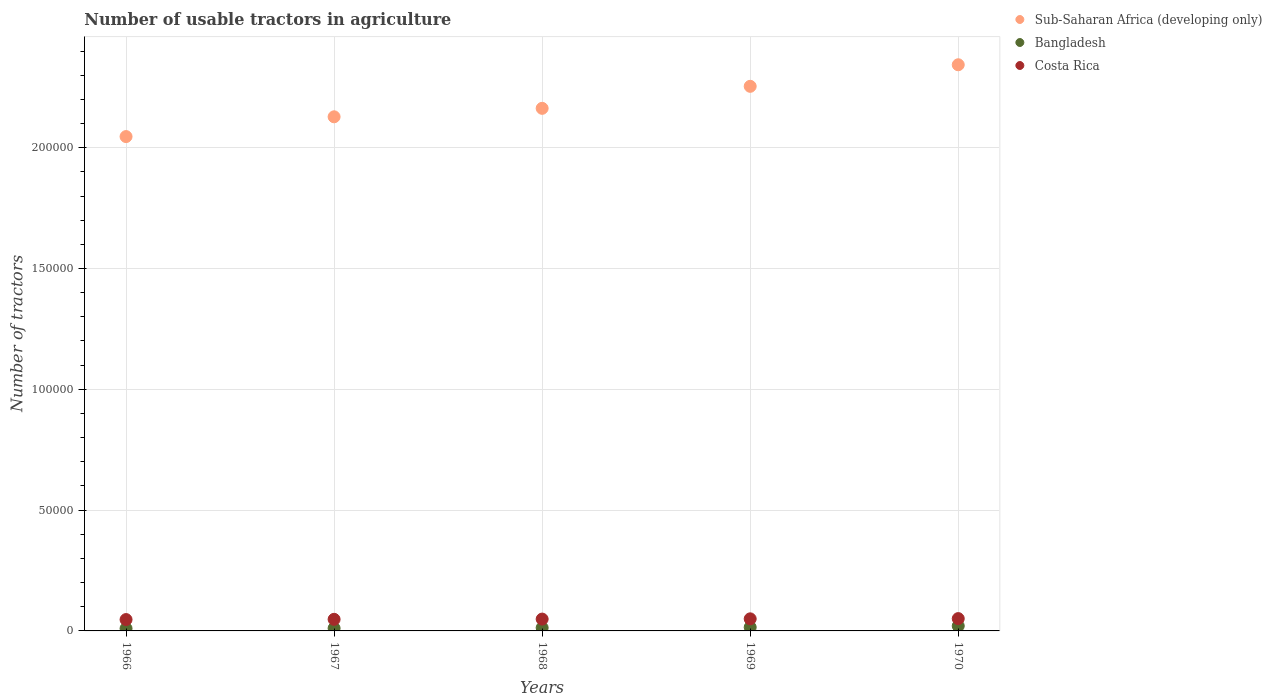Is the number of dotlines equal to the number of legend labels?
Offer a terse response. Yes. What is the number of usable tractors in agriculture in Costa Rica in 1966?
Your answer should be compact. 4700. Across all years, what is the maximum number of usable tractors in agriculture in Bangladesh?
Offer a terse response. 2072. Across all years, what is the minimum number of usable tractors in agriculture in Sub-Saharan Africa (developing only)?
Provide a short and direct response. 2.05e+05. In which year was the number of usable tractors in agriculture in Sub-Saharan Africa (developing only) maximum?
Offer a terse response. 1970. In which year was the number of usable tractors in agriculture in Bangladesh minimum?
Your response must be concise. 1966. What is the total number of usable tractors in agriculture in Bangladesh in the graph?
Provide a short and direct response. 6972. What is the difference between the number of usable tractors in agriculture in Bangladesh in 1968 and that in 1969?
Provide a short and direct response. -200. What is the difference between the number of usable tractors in agriculture in Sub-Saharan Africa (developing only) in 1966 and the number of usable tractors in agriculture in Costa Rica in 1968?
Provide a short and direct response. 2.00e+05. What is the average number of usable tractors in agriculture in Sub-Saharan Africa (developing only) per year?
Keep it short and to the point. 2.19e+05. In the year 1967, what is the difference between the number of usable tractors in agriculture in Bangladesh and number of usable tractors in agriculture in Costa Rica?
Make the answer very short. -3700. What is the ratio of the number of usable tractors in agriculture in Sub-Saharan Africa (developing only) in 1966 to that in 1968?
Provide a short and direct response. 0.95. Is the difference between the number of usable tractors in agriculture in Bangladesh in 1966 and 1969 greater than the difference between the number of usable tractors in agriculture in Costa Rica in 1966 and 1969?
Provide a short and direct response. No. What is the difference between the highest and the lowest number of usable tractors in agriculture in Sub-Saharan Africa (developing only)?
Give a very brief answer. 2.97e+04. In how many years, is the number of usable tractors in agriculture in Sub-Saharan Africa (developing only) greater than the average number of usable tractors in agriculture in Sub-Saharan Africa (developing only) taken over all years?
Make the answer very short. 2. Is the number of usable tractors in agriculture in Bangladesh strictly less than the number of usable tractors in agriculture in Sub-Saharan Africa (developing only) over the years?
Keep it short and to the point. Yes. How many years are there in the graph?
Ensure brevity in your answer.  5. What is the difference between two consecutive major ticks on the Y-axis?
Provide a short and direct response. 5.00e+04. Does the graph contain any zero values?
Your response must be concise. No. How many legend labels are there?
Your answer should be compact. 3. What is the title of the graph?
Ensure brevity in your answer.  Number of usable tractors in agriculture. What is the label or title of the X-axis?
Your answer should be very brief. Years. What is the label or title of the Y-axis?
Keep it short and to the point. Number of tractors. What is the Number of tractors of Sub-Saharan Africa (developing only) in 1966?
Provide a short and direct response. 2.05e+05. What is the Number of tractors in Costa Rica in 1966?
Ensure brevity in your answer.  4700. What is the Number of tractors of Sub-Saharan Africa (developing only) in 1967?
Your answer should be very brief. 2.13e+05. What is the Number of tractors in Bangladesh in 1967?
Your answer should be very brief. 1100. What is the Number of tractors in Costa Rica in 1967?
Your response must be concise. 4800. What is the Number of tractors of Sub-Saharan Africa (developing only) in 1968?
Offer a very short reply. 2.16e+05. What is the Number of tractors in Bangladesh in 1968?
Give a very brief answer. 1300. What is the Number of tractors of Costa Rica in 1968?
Keep it short and to the point. 4900. What is the Number of tractors in Sub-Saharan Africa (developing only) in 1969?
Your answer should be compact. 2.25e+05. What is the Number of tractors in Bangladesh in 1969?
Offer a very short reply. 1500. What is the Number of tractors of Sub-Saharan Africa (developing only) in 1970?
Make the answer very short. 2.34e+05. What is the Number of tractors of Bangladesh in 1970?
Offer a very short reply. 2072. What is the Number of tractors of Costa Rica in 1970?
Provide a succinct answer. 5100. Across all years, what is the maximum Number of tractors in Sub-Saharan Africa (developing only)?
Provide a short and direct response. 2.34e+05. Across all years, what is the maximum Number of tractors in Bangladesh?
Provide a short and direct response. 2072. Across all years, what is the maximum Number of tractors of Costa Rica?
Your response must be concise. 5100. Across all years, what is the minimum Number of tractors in Sub-Saharan Africa (developing only)?
Provide a short and direct response. 2.05e+05. Across all years, what is the minimum Number of tractors of Costa Rica?
Your answer should be compact. 4700. What is the total Number of tractors of Sub-Saharan Africa (developing only) in the graph?
Give a very brief answer. 1.09e+06. What is the total Number of tractors in Bangladesh in the graph?
Make the answer very short. 6972. What is the total Number of tractors in Costa Rica in the graph?
Your answer should be very brief. 2.45e+04. What is the difference between the Number of tractors of Sub-Saharan Africa (developing only) in 1966 and that in 1967?
Make the answer very short. -8186. What is the difference between the Number of tractors in Bangladesh in 1966 and that in 1967?
Offer a very short reply. -100. What is the difference between the Number of tractors of Costa Rica in 1966 and that in 1967?
Your answer should be compact. -100. What is the difference between the Number of tractors of Sub-Saharan Africa (developing only) in 1966 and that in 1968?
Keep it short and to the point. -1.17e+04. What is the difference between the Number of tractors of Bangladesh in 1966 and that in 1968?
Ensure brevity in your answer.  -300. What is the difference between the Number of tractors in Costa Rica in 1966 and that in 1968?
Your answer should be very brief. -200. What is the difference between the Number of tractors in Sub-Saharan Africa (developing only) in 1966 and that in 1969?
Keep it short and to the point. -2.08e+04. What is the difference between the Number of tractors in Bangladesh in 1966 and that in 1969?
Your answer should be compact. -500. What is the difference between the Number of tractors in Costa Rica in 1966 and that in 1969?
Your answer should be very brief. -300. What is the difference between the Number of tractors in Sub-Saharan Africa (developing only) in 1966 and that in 1970?
Offer a terse response. -2.97e+04. What is the difference between the Number of tractors in Bangladesh in 1966 and that in 1970?
Your answer should be compact. -1072. What is the difference between the Number of tractors in Costa Rica in 1966 and that in 1970?
Provide a short and direct response. -400. What is the difference between the Number of tractors in Sub-Saharan Africa (developing only) in 1967 and that in 1968?
Ensure brevity in your answer.  -3501. What is the difference between the Number of tractors of Bangladesh in 1967 and that in 1968?
Your response must be concise. -200. What is the difference between the Number of tractors of Costa Rica in 1967 and that in 1968?
Make the answer very short. -100. What is the difference between the Number of tractors of Sub-Saharan Africa (developing only) in 1967 and that in 1969?
Ensure brevity in your answer.  -1.26e+04. What is the difference between the Number of tractors of Bangladesh in 1967 and that in 1969?
Ensure brevity in your answer.  -400. What is the difference between the Number of tractors of Costa Rica in 1967 and that in 1969?
Provide a short and direct response. -200. What is the difference between the Number of tractors in Sub-Saharan Africa (developing only) in 1967 and that in 1970?
Your answer should be very brief. -2.15e+04. What is the difference between the Number of tractors of Bangladesh in 1967 and that in 1970?
Offer a terse response. -972. What is the difference between the Number of tractors in Costa Rica in 1967 and that in 1970?
Offer a terse response. -300. What is the difference between the Number of tractors in Sub-Saharan Africa (developing only) in 1968 and that in 1969?
Provide a succinct answer. -9111. What is the difference between the Number of tractors of Bangladesh in 1968 and that in 1969?
Ensure brevity in your answer.  -200. What is the difference between the Number of tractors of Costa Rica in 1968 and that in 1969?
Make the answer very short. -100. What is the difference between the Number of tractors in Sub-Saharan Africa (developing only) in 1968 and that in 1970?
Your answer should be very brief. -1.80e+04. What is the difference between the Number of tractors in Bangladesh in 1968 and that in 1970?
Make the answer very short. -772. What is the difference between the Number of tractors in Costa Rica in 1968 and that in 1970?
Your answer should be compact. -200. What is the difference between the Number of tractors in Sub-Saharan Africa (developing only) in 1969 and that in 1970?
Your answer should be very brief. -8924. What is the difference between the Number of tractors of Bangladesh in 1969 and that in 1970?
Offer a very short reply. -572. What is the difference between the Number of tractors in Costa Rica in 1969 and that in 1970?
Give a very brief answer. -100. What is the difference between the Number of tractors in Sub-Saharan Africa (developing only) in 1966 and the Number of tractors in Bangladesh in 1967?
Your answer should be very brief. 2.03e+05. What is the difference between the Number of tractors in Sub-Saharan Africa (developing only) in 1966 and the Number of tractors in Costa Rica in 1967?
Provide a succinct answer. 2.00e+05. What is the difference between the Number of tractors in Bangladesh in 1966 and the Number of tractors in Costa Rica in 1967?
Give a very brief answer. -3800. What is the difference between the Number of tractors of Sub-Saharan Africa (developing only) in 1966 and the Number of tractors of Bangladesh in 1968?
Your answer should be very brief. 2.03e+05. What is the difference between the Number of tractors of Sub-Saharan Africa (developing only) in 1966 and the Number of tractors of Costa Rica in 1968?
Your answer should be very brief. 2.00e+05. What is the difference between the Number of tractors of Bangladesh in 1966 and the Number of tractors of Costa Rica in 1968?
Keep it short and to the point. -3900. What is the difference between the Number of tractors in Sub-Saharan Africa (developing only) in 1966 and the Number of tractors in Bangladesh in 1969?
Your answer should be compact. 2.03e+05. What is the difference between the Number of tractors of Sub-Saharan Africa (developing only) in 1966 and the Number of tractors of Costa Rica in 1969?
Your answer should be compact. 2.00e+05. What is the difference between the Number of tractors of Bangladesh in 1966 and the Number of tractors of Costa Rica in 1969?
Ensure brevity in your answer.  -4000. What is the difference between the Number of tractors in Sub-Saharan Africa (developing only) in 1966 and the Number of tractors in Bangladesh in 1970?
Offer a terse response. 2.03e+05. What is the difference between the Number of tractors in Sub-Saharan Africa (developing only) in 1966 and the Number of tractors in Costa Rica in 1970?
Offer a very short reply. 1.99e+05. What is the difference between the Number of tractors of Bangladesh in 1966 and the Number of tractors of Costa Rica in 1970?
Offer a very short reply. -4100. What is the difference between the Number of tractors of Sub-Saharan Africa (developing only) in 1967 and the Number of tractors of Bangladesh in 1968?
Make the answer very short. 2.11e+05. What is the difference between the Number of tractors of Sub-Saharan Africa (developing only) in 1967 and the Number of tractors of Costa Rica in 1968?
Your response must be concise. 2.08e+05. What is the difference between the Number of tractors of Bangladesh in 1967 and the Number of tractors of Costa Rica in 1968?
Give a very brief answer. -3800. What is the difference between the Number of tractors of Sub-Saharan Africa (developing only) in 1967 and the Number of tractors of Bangladesh in 1969?
Make the answer very short. 2.11e+05. What is the difference between the Number of tractors of Sub-Saharan Africa (developing only) in 1967 and the Number of tractors of Costa Rica in 1969?
Your response must be concise. 2.08e+05. What is the difference between the Number of tractors in Bangladesh in 1967 and the Number of tractors in Costa Rica in 1969?
Provide a short and direct response. -3900. What is the difference between the Number of tractors in Sub-Saharan Africa (developing only) in 1967 and the Number of tractors in Bangladesh in 1970?
Your answer should be very brief. 2.11e+05. What is the difference between the Number of tractors in Sub-Saharan Africa (developing only) in 1967 and the Number of tractors in Costa Rica in 1970?
Provide a succinct answer. 2.08e+05. What is the difference between the Number of tractors in Bangladesh in 1967 and the Number of tractors in Costa Rica in 1970?
Offer a very short reply. -4000. What is the difference between the Number of tractors in Sub-Saharan Africa (developing only) in 1968 and the Number of tractors in Bangladesh in 1969?
Provide a succinct answer. 2.15e+05. What is the difference between the Number of tractors in Sub-Saharan Africa (developing only) in 1968 and the Number of tractors in Costa Rica in 1969?
Your answer should be very brief. 2.11e+05. What is the difference between the Number of tractors in Bangladesh in 1968 and the Number of tractors in Costa Rica in 1969?
Provide a short and direct response. -3700. What is the difference between the Number of tractors in Sub-Saharan Africa (developing only) in 1968 and the Number of tractors in Bangladesh in 1970?
Give a very brief answer. 2.14e+05. What is the difference between the Number of tractors of Sub-Saharan Africa (developing only) in 1968 and the Number of tractors of Costa Rica in 1970?
Ensure brevity in your answer.  2.11e+05. What is the difference between the Number of tractors of Bangladesh in 1968 and the Number of tractors of Costa Rica in 1970?
Offer a very short reply. -3800. What is the difference between the Number of tractors of Sub-Saharan Africa (developing only) in 1969 and the Number of tractors of Bangladesh in 1970?
Your answer should be compact. 2.23e+05. What is the difference between the Number of tractors of Sub-Saharan Africa (developing only) in 1969 and the Number of tractors of Costa Rica in 1970?
Keep it short and to the point. 2.20e+05. What is the difference between the Number of tractors of Bangladesh in 1969 and the Number of tractors of Costa Rica in 1970?
Offer a terse response. -3600. What is the average Number of tractors of Sub-Saharan Africa (developing only) per year?
Keep it short and to the point. 2.19e+05. What is the average Number of tractors of Bangladesh per year?
Keep it short and to the point. 1394.4. What is the average Number of tractors of Costa Rica per year?
Your response must be concise. 4900. In the year 1966, what is the difference between the Number of tractors of Sub-Saharan Africa (developing only) and Number of tractors of Bangladesh?
Give a very brief answer. 2.04e+05. In the year 1966, what is the difference between the Number of tractors in Sub-Saharan Africa (developing only) and Number of tractors in Costa Rica?
Give a very brief answer. 2.00e+05. In the year 1966, what is the difference between the Number of tractors in Bangladesh and Number of tractors in Costa Rica?
Ensure brevity in your answer.  -3700. In the year 1967, what is the difference between the Number of tractors in Sub-Saharan Africa (developing only) and Number of tractors in Bangladesh?
Your answer should be very brief. 2.12e+05. In the year 1967, what is the difference between the Number of tractors of Sub-Saharan Africa (developing only) and Number of tractors of Costa Rica?
Offer a very short reply. 2.08e+05. In the year 1967, what is the difference between the Number of tractors of Bangladesh and Number of tractors of Costa Rica?
Give a very brief answer. -3700. In the year 1968, what is the difference between the Number of tractors in Sub-Saharan Africa (developing only) and Number of tractors in Bangladesh?
Keep it short and to the point. 2.15e+05. In the year 1968, what is the difference between the Number of tractors in Sub-Saharan Africa (developing only) and Number of tractors in Costa Rica?
Give a very brief answer. 2.11e+05. In the year 1968, what is the difference between the Number of tractors of Bangladesh and Number of tractors of Costa Rica?
Provide a succinct answer. -3600. In the year 1969, what is the difference between the Number of tractors in Sub-Saharan Africa (developing only) and Number of tractors in Bangladesh?
Ensure brevity in your answer.  2.24e+05. In the year 1969, what is the difference between the Number of tractors of Sub-Saharan Africa (developing only) and Number of tractors of Costa Rica?
Keep it short and to the point. 2.20e+05. In the year 1969, what is the difference between the Number of tractors of Bangladesh and Number of tractors of Costa Rica?
Your response must be concise. -3500. In the year 1970, what is the difference between the Number of tractors of Sub-Saharan Africa (developing only) and Number of tractors of Bangladesh?
Offer a very short reply. 2.32e+05. In the year 1970, what is the difference between the Number of tractors of Sub-Saharan Africa (developing only) and Number of tractors of Costa Rica?
Your answer should be very brief. 2.29e+05. In the year 1970, what is the difference between the Number of tractors in Bangladesh and Number of tractors in Costa Rica?
Provide a succinct answer. -3028. What is the ratio of the Number of tractors in Sub-Saharan Africa (developing only) in 1966 to that in 1967?
Your response must be concise. 0.96. What is the ratio of the Number of tractors in Bangladesh in 1966 to that in 1967?
Offer a very short reply. 0.91. What is the ratio of the Number of tractors of Costa Rica in 1966 to that in 1967?
Offer a very short reply. 0.98. What is the ratio of the Number of tractors in Sub-Saharan Africa (developing only) in 1966 to that in 1968?
Give a very brief answer. 0.95. What is the ratio of the Number of tractors of Bangladesh in 1966 to that in 1968?
Provide a succinct answer. 0.77. What is the ratio of the Number of tractors of Costa Rica in 1966 to that in 1968?
Keep it short and to the point. 0.96. What is the ratio of the Number of tractors in Sub-Saharan Africa (developing only) in 1966 to that in 1969?
Ensure brevity in your answer.  0.91. What is the ratio of the Number of tractors in Bangladesh in 1966 to that in 1969?
Your answer should be very brief. 0.67. What is the ratio of the Number of tractors of Costa Rica in 1966 to that in 1969?
Give a very brief answer. 0.94. What is the ratio of the Number of tractors in Sub-Saharan Africa (developing only) in 1966 to that in 1970?
Keep it short and to the point. 0.87. What is the ratio of the Number of tractors in Bangladesh in 1966 to that in 1970?
Give a very brief answer. 0.48. What is the ratio of the Number of tractors of Costa Rica in 1966 to that in 1970?
Ensure brevity in your answer.  0.92. What is the ratio of the Number of tractors of Sub-Saharan Africa (developing only) in 1967 to that in 1968?
Offer a very short reply. 0.98. What is the ratio of the Number of tractors of Bangladesh in 1967 to that in 1968?
Make the answer very short. 0.85. What is the ratio of the Number of tractors of Costa Rica in 1967 to that in 1968?
Your answer should be very brief. 0.98. What is the ratio of the Number of tractors of Sub-Saharan Africa (developing only) in 1967 to that in 1969?
Your answer should be very brief. 0.94. What is the ratio of the Number of tractors of Bangladesh in 1967 to that in 1969?
Your answer should be compact. 0.73. What is the ratio of the Number of tractors in Sub-Saharan Africa (developing only) in 1967 to that in 1970?
Your response must be concise. 0.91. What is the ratio of the Number of tractors of Bangladesh in 1967 to that in 1970?
Your answer should be very brief. 0.53. What is the ratio of the Number of tractors in Costa Rica in 1967 to that in 1970?
Make the answer very short. 0.94. What is the ratio of the Number of tractors in Sub-Saharan Africa (developing only) in 1968 to that in 1969?
Offer a terse response. 0.96. What is the ratio of the Number of tractors of Bangladesh in 1968 to that in 1969?
Ensure brevity in your answer.  0.87. What is the ratio of the Number of tractors in Costa Rica in 1968 to that in 1969?
Provide a short and direct response. 0.98. What is the ratio of the Number of tractors of Sub-Saharan Africa (developing only) in 1968 to that in 1970?
Keep it short and to the point. 0.92. What is the ratio of the Number of tractors in Bangladesh in 1968 to that in 1970?
Offer a terse response. 0.63. What is the ratio of the Number of tractors of Costa Rica in 1968 to that in 1970?
Offer a very short reply. 0.96. What is the ratio of the Number of tractors of Sub-Saharan Africa (developing only) in 1969 to that in 1970?
Offer a terse response. 0.96. What is the ratio of the Number of tractors of Bangladesh in 1969 to that in 1970?
Make the answer very short. 0.72. What is the ratio of the Number of tractors of Costa Rica in 1969 to that in 1970?
Offer a terse response. 0.98. What is the difference between the highest and the second highest Number of tractors of Sub-Saharan Africa (developing only)?
Your answer should be compact. 8924. What is the difference between the highest and the second highest Number of tractors in Bangladesh?
Your answer should be very brief. 572. What is the difference between the highest and the lowest Number of tractors of Sub-Saharan Africa (developing only)?
Offer a terse response. 2.97e+04. What is the difference between the highest and the lowest Number of tractors of Bangladesh?
Your answer should be compact. 1072. What is the difference between the highest and the lowest Number of tractors in Costa Rica?
Give a very brief answer. 400. 